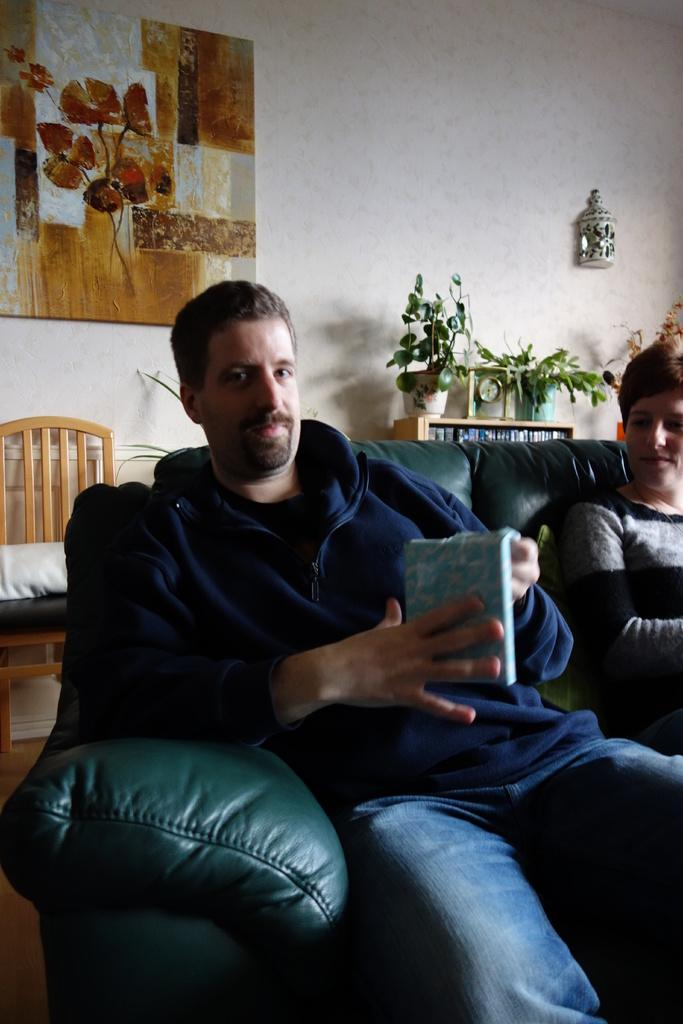How many people are sitting on the couch in the image? There are two men sitting on the same couch in the image. What can be seen on the wall in the background? There is a frame attached to the wall in the background. What other furniture is visible in the background? There is a chair and a plant in the background. What type of objects can be seen in the background related to reading or learning? There are books in the background. What type of stamp can be seen on the man's forehead in the image? There is no stamp visible on any of the men's foreheads in the image. 